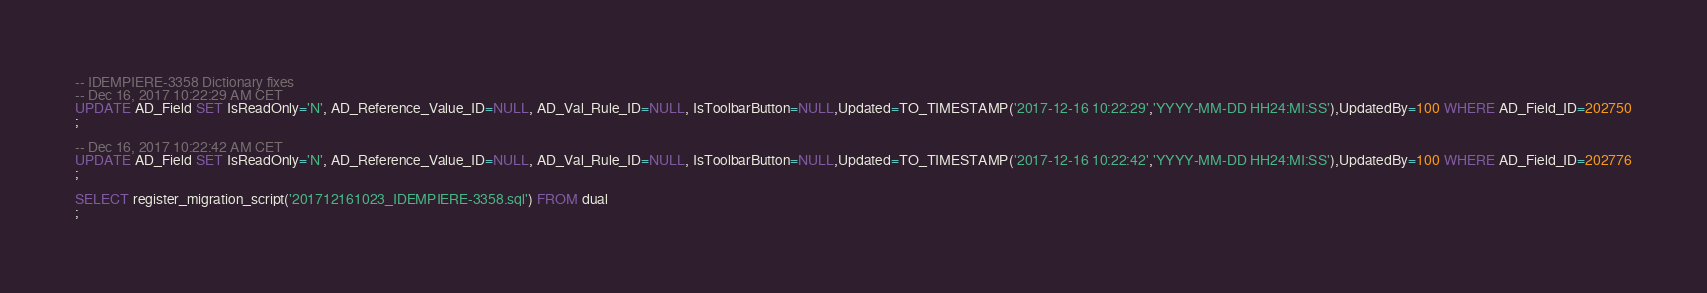Convert code to text. <code><loc_0><loc_0><loc_500><loc_500><_SQL_>-- IDEMPIERE-3358 Dictionary fixes
-- Dec 16, 2017 10:22:29 AM CET
UPDATE AD_Field SET IsReadOnly='N', AD_Reference_Value_ID=NULL, AD_Val_Rule_ID=NULL, IsToolbarButton=NULL,Updated=TO_TIMESTAMP('2017-12-16 10:22:29','YYYY-MM-DD HH24:MI:SS'),UpdatedBy=100 WHERE AD_Field_ID=202750
;

-- Dec 16, 2017 10:22:42 AM CET
UPDATE AD_Field SET IsReadOnly='N', AD_Reference_Value_ID=NULL, AD_Val_Rule_ID=NULL, IsToolbarButton=NULL,Updated=TO_TIMESTAMP('2017-12-16 10:22:42','YYYY-MM-DD HH24:MI:SS'),UpdatedBy=100 WHERE AD_Field_ID=202776
;

SELECT register_migration_script('201712161023_IDEMPIERE-3358.sql') FROM dual
;

</code> 